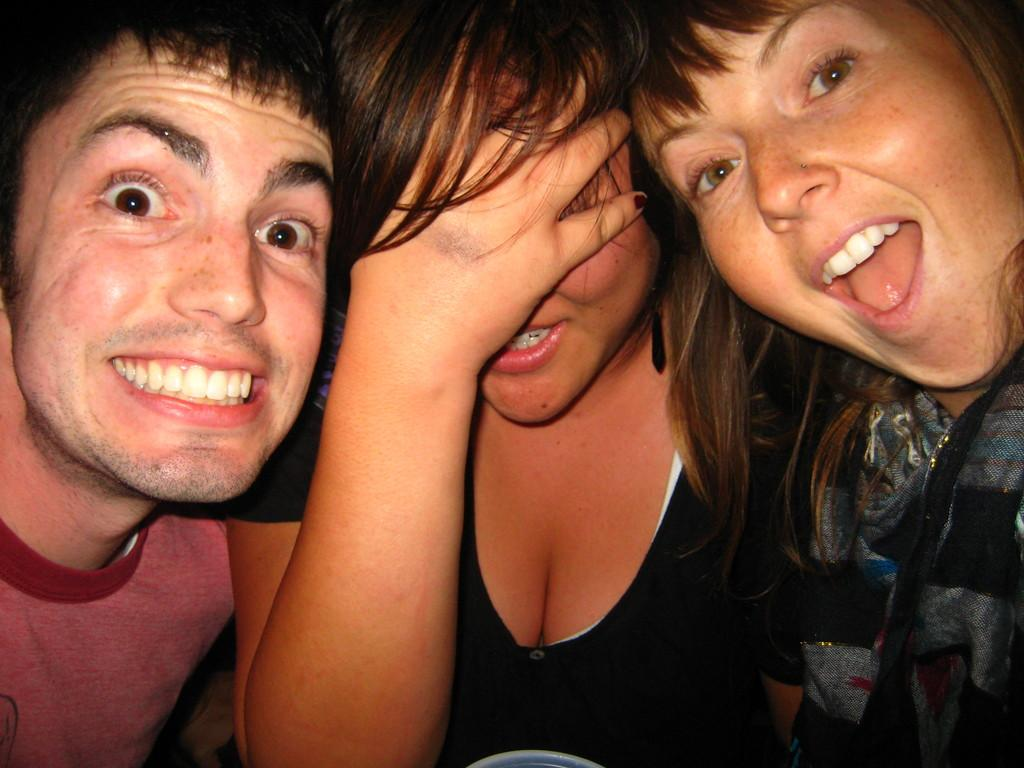How many people are in the image? There are three persons in the image. What is the facial expression of the people in the image? All three persons are smiling. Can you describe the woman in the middle? The woman in the middle is hiding her face with her hand. What direction is the faucet facing in the image? There is no faucet present in the image. What type of yam is being used as a prop in the image? There is no yam present in the image. 